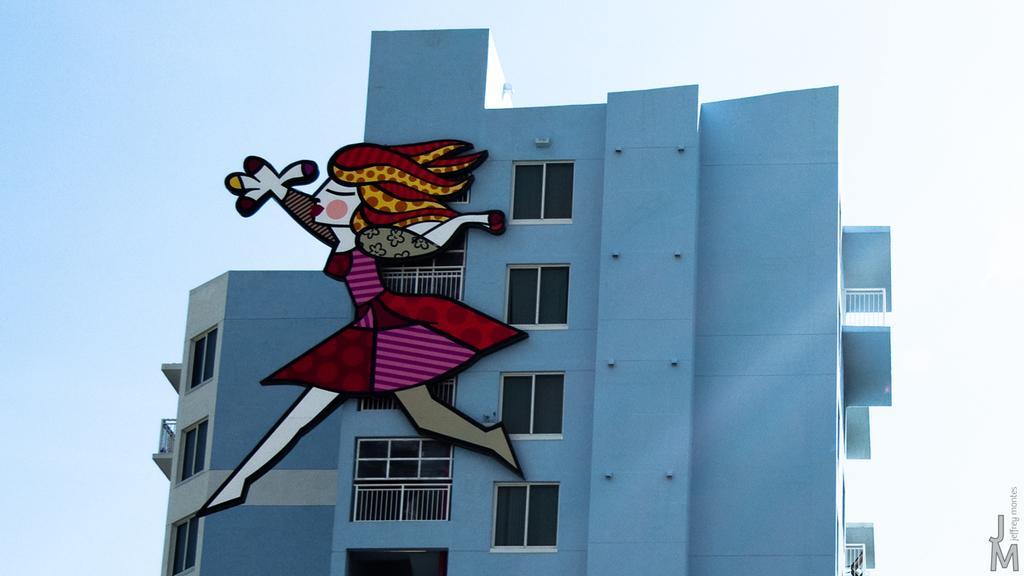Can you describe this image briefly? In this image I can see blue colour building, number of windows and here I can see a cartoon character. I can also see the sky in background. 